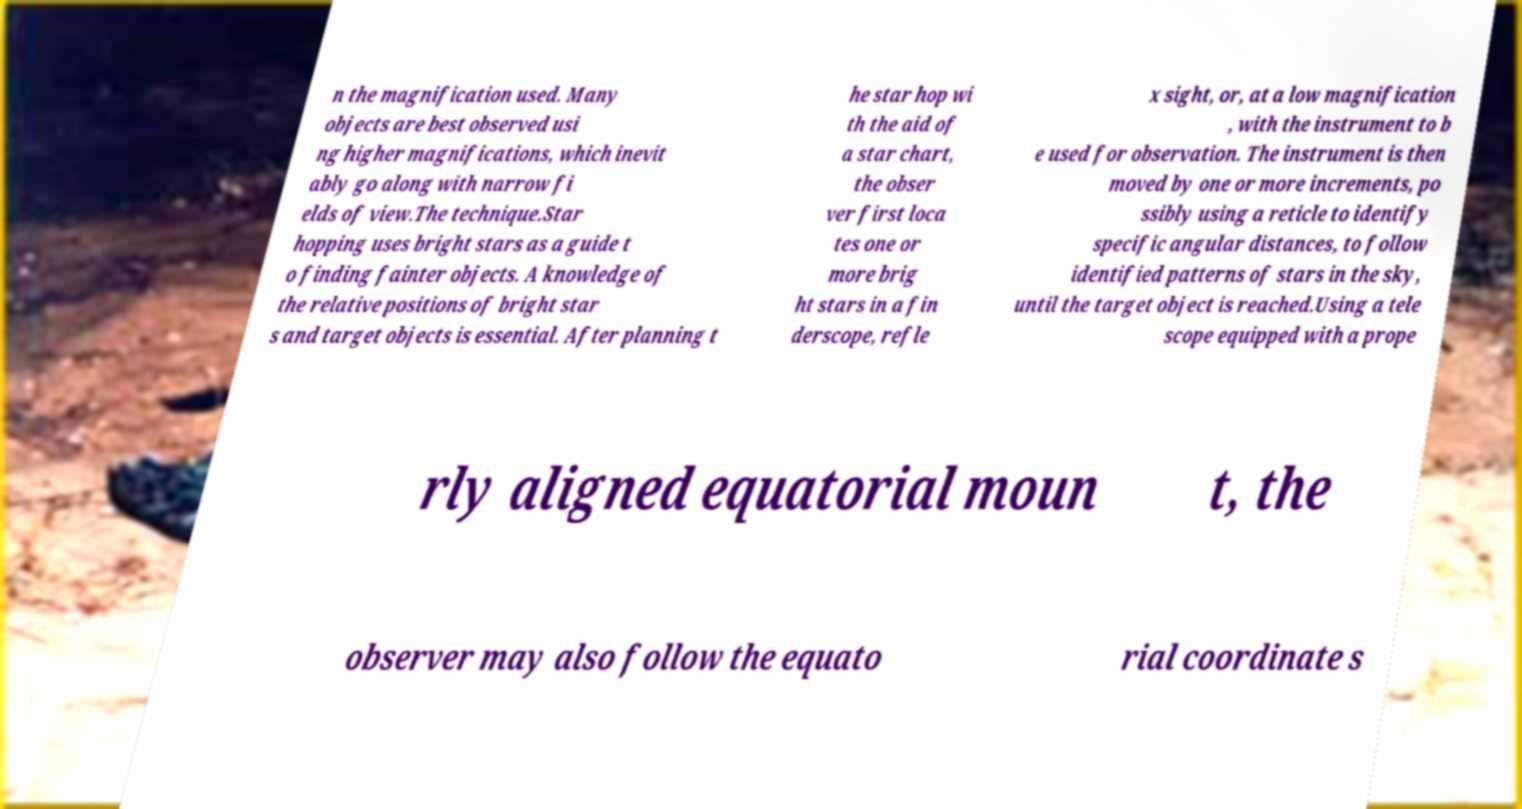What messages or text are displayed in this image? I need them in a readable, typed format. n the magnification used. Many objects are best observed usi ng higher magnifications, which inevit ably go along with narrow fi elds of view.The technique.Star hopping uses bright stars as a guide t o finding fainter objects. A knowledge of the relative positions of bright star s and target objects is essential. After planning t he star hop wi th the aid of a star chart, the obser ver first loca tes one or more brig ht stars in a fin derscope, refle x sight, or, at a low magnification , with the instrument to b e used for observation. The instrument is then moved by one or more increments, po ssibly using a reticle to identify specific angular distances, to follow identified patterns of stars in the sky, until the target object is reached.Using a tele scope equipped with a prope rly aligned equatorial moun t, the observer may also follow the equato rial coordinate s 